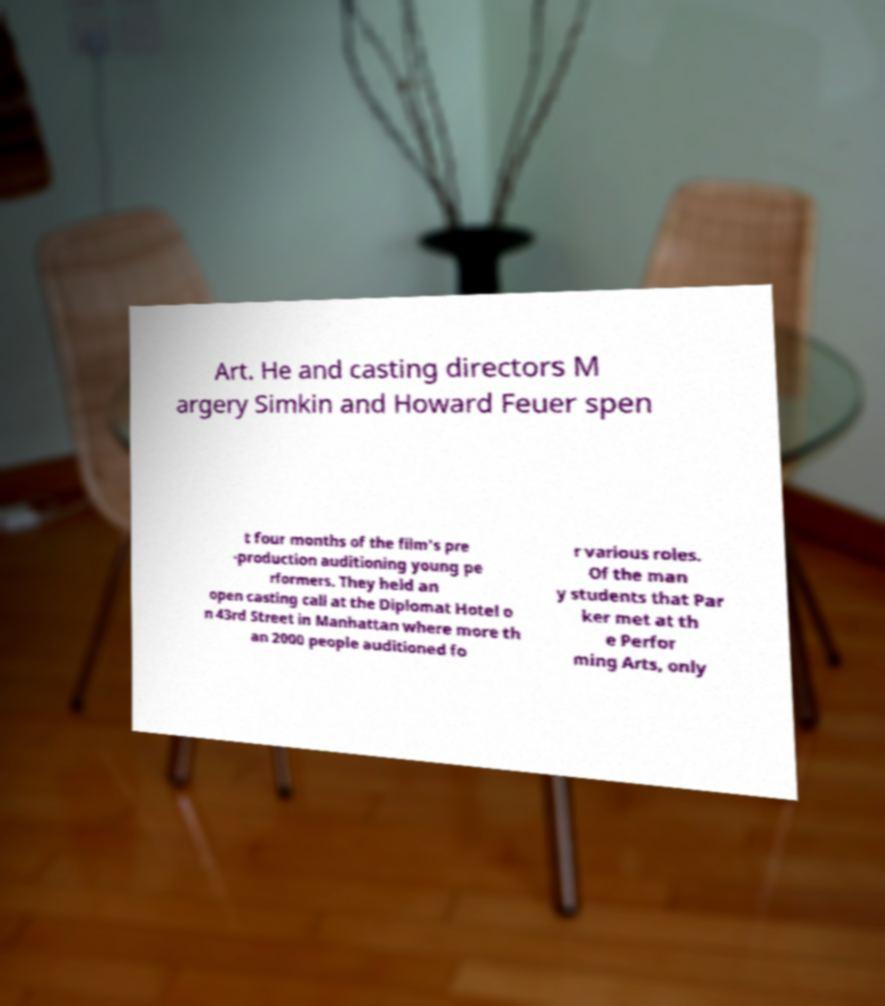There's text embedded in this image that I need extracted. Can you transcribe it verbatim? Art. He and casting directors M argery Simkin and Howard Feuer spen t four months of the film's pre -production auditioning young pe rformers. They held an open casting call at the Diplomat Hotel o n 43rd Street in Manhattan where more th an 2000 people auditioned fo r various roles. Of the man y students that Par ker met at th e Perfor ming Arts, only 